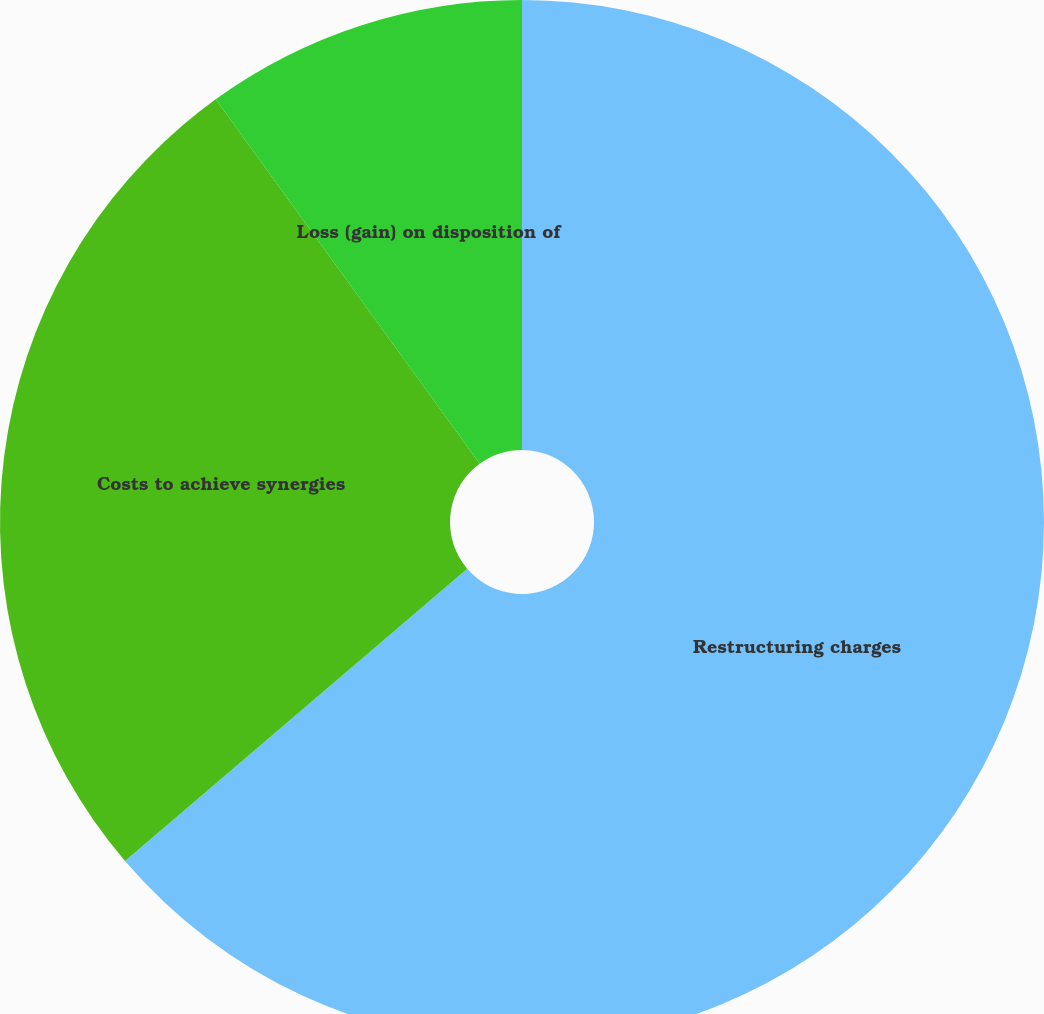<chart> <loc_0><loc_0><loc_500><loc_500><pie_chart><fcel>Restructuring charges<fcel>Costs to achieve synergies<fcel>Loss (gain) on disposition of<nl><fcel>63.75%<fcel>26.27%<fcel>9.98%<nl></chart> 